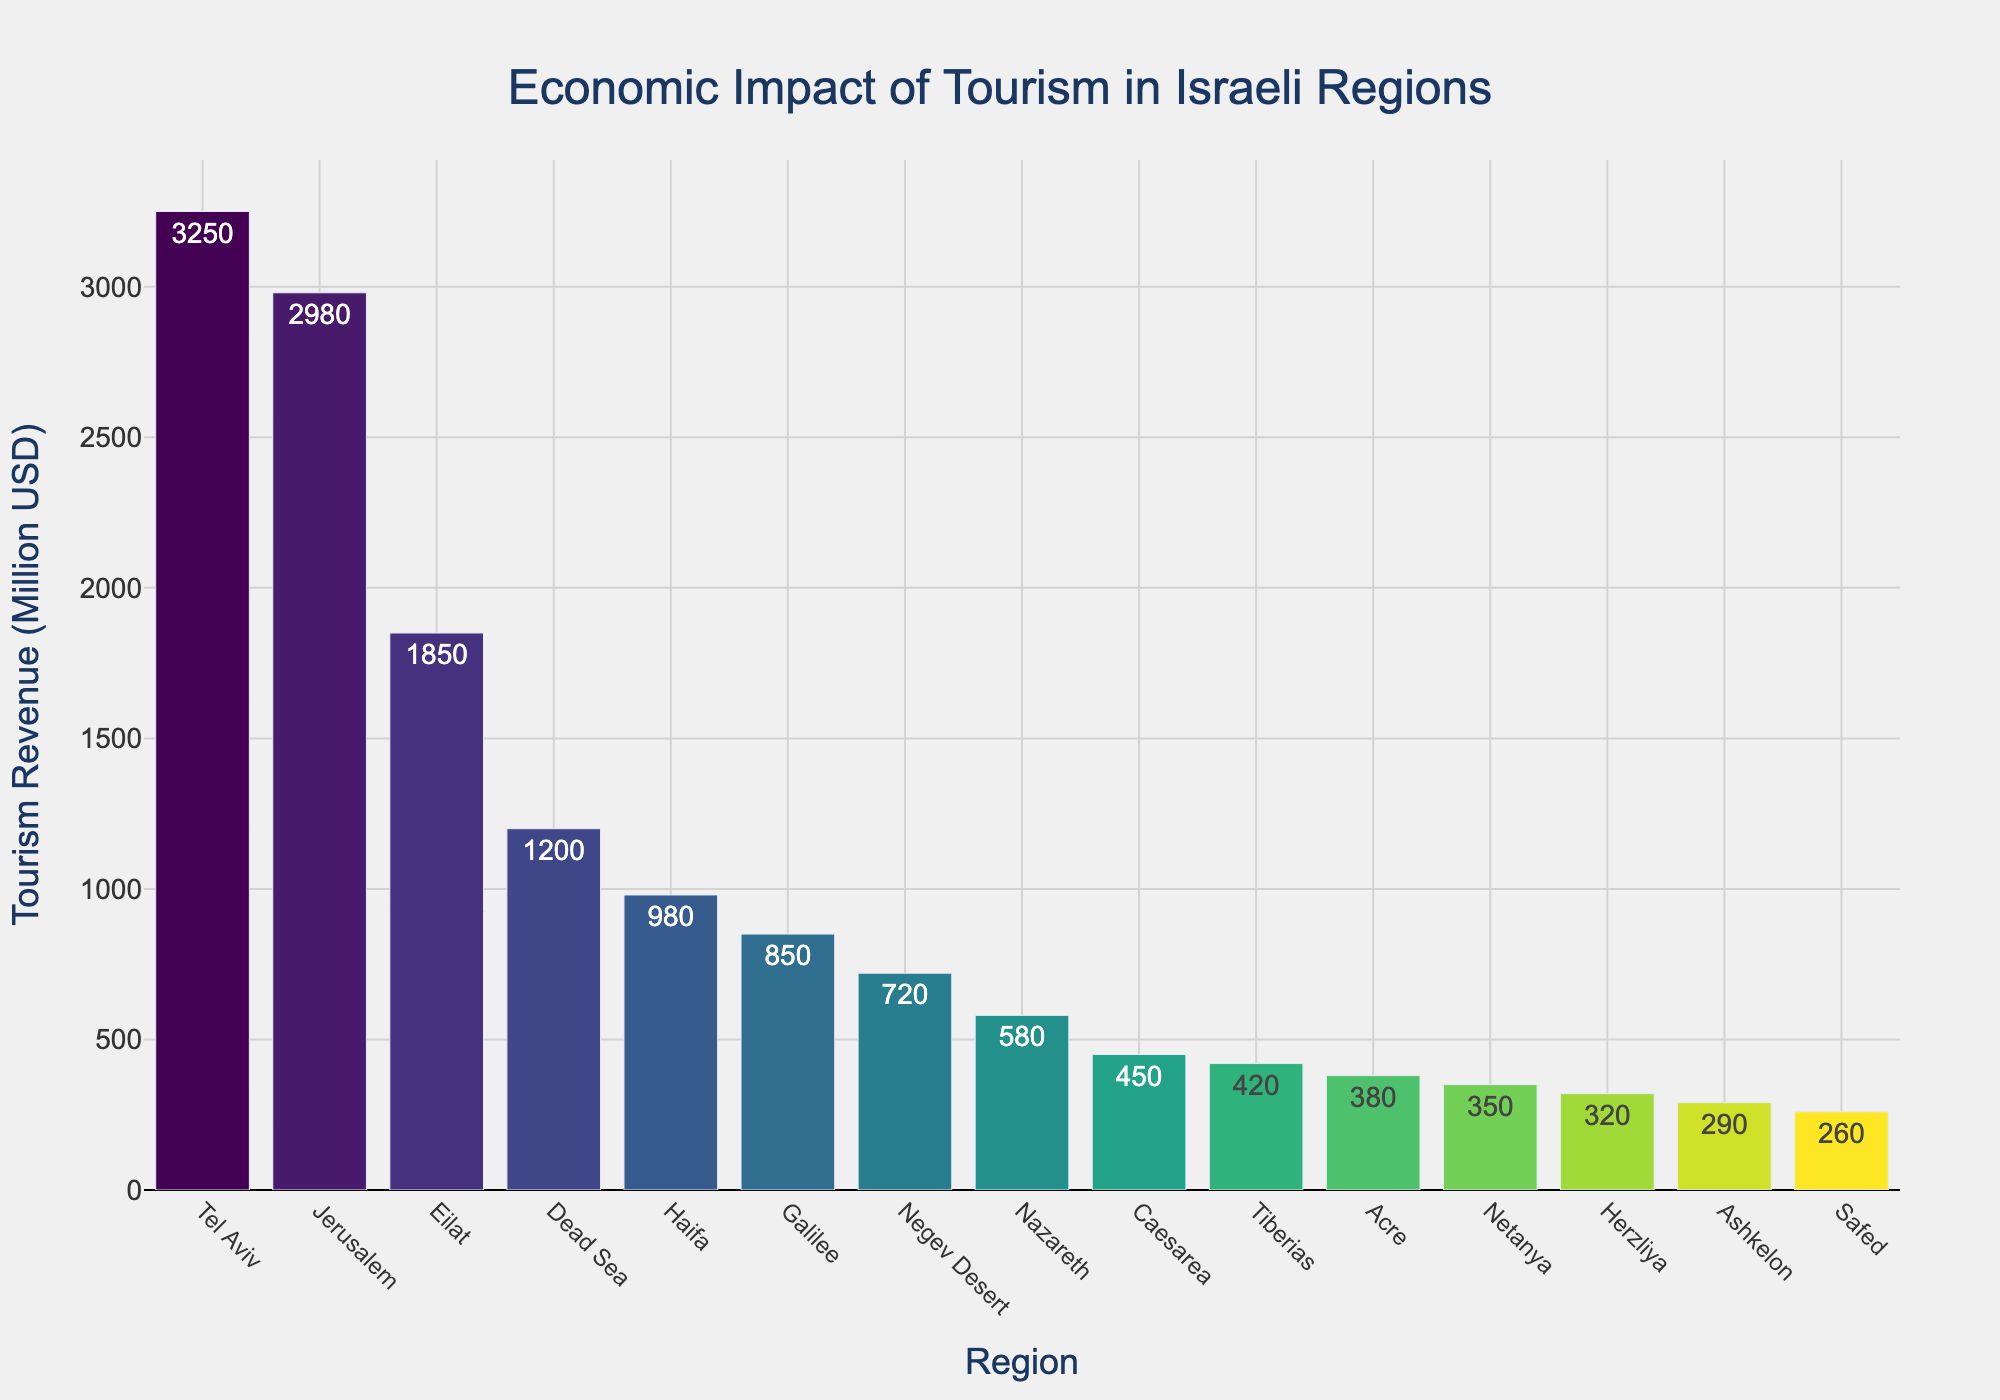What region generates the highest tourism revenue? The bar chart shows the tourism revenues of various regions in descending order. The tallest bar corresponds to Tel Aviv.
Answer: Tel Aviv Which two regions together nearly match the tourism revenue generated by Tel Aviv? Tel Aviv has the highest revenue with 3250 million USD. Jerusalem and Eilat, the next two regions, have revenues of 2980 million USD and 1850 million USD respectively. 2980 + 1850 = 4830, which is higher than 3250, but Jerusalem and the next highest region below Eilat are Jerusalem (2980) + Eilat (1850) = 4830, which is greater than Tel Aviv (3250). Therefore, the two closest regions combined to Tel Aviv's revenue are Jerusalem and Eilat
Answer: None What is the difference in tourism revenue between Haifa and Eilat? Haifa generates 980 million USD, while Eilat generates 1850 million USD. The difference between them is 1850 - 980 = 870 million USD.
Answer: 870 million USD How much more revenue does Jerusalem generate compared to the Negev Desert? Jerusalem generates 2980 million USD, while the Negev Desert generates 720 million USD. The difference in revenue is 2980 - 720 = 2260 million USD.
Answer: 2260 million USD Which region has the least tourism revenue, and what is its amount? The shortest bar represents the region with the lowest tourism revenue. Safed has the smallest bar at 260 million USD.
Answer: Safed, 260 million USD How does the tourism revenue of Tiberias compare to that of Acre? According to the bar chart, Tiberias has a tourism revenue of 420 million USD, while Acre has a revenue of 380 million USD. Since 420 is greater than 380, Tiberias generates more revenue than Acre.
Answer: Tiberias generates more What is the total tourism revenue for Tel Aviv, Jerusalem, and Eilat combined? The sum of the tourism revenues for Tel Aviv, Jerusalem, and Eilat is 3250 + 2980 + 1850 = 8080 million USD.
Answer: 8080 million USD Which region stands out visually with the highest shade in the 'Viridis' color scale used? The bar representing Tel Aviv stands out the most visually, as it is the tallest and likely has the highest shade in the color scale.
Answer: Tel Aviv What is the average tourism revenue of Galilee, Negev Desert, Nazareth, and Caesarea? The revenues for Galilee, Negev Desert, Nazareth, and Caesarea are 850, 720, 580, and 450 million USD respectively. The sum is 850 + 720 + 580 + 450 = 2600. The average is 2600 / 4 = 650 million USD.
Answer: 650 million USD 